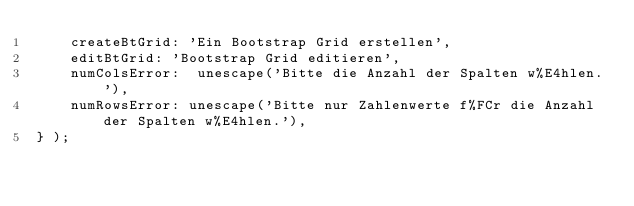<code> <loc_0><loc_0><loc_500><loc_500><_JavaScript_>	createBtGrid: 'Ein Bootstrap Grid erstellen',
	editBtGrid: 'Bootstrap Grid editieren',
	numColsError:  unescape('Bitte die Anzahl der Spalten w%E4hlen.'),
	numRowsError: unescape('Bitte nur Zahlenwerte f%FCr die Anzahl der Spalten w%E4hlen.'),
} );
</code> 